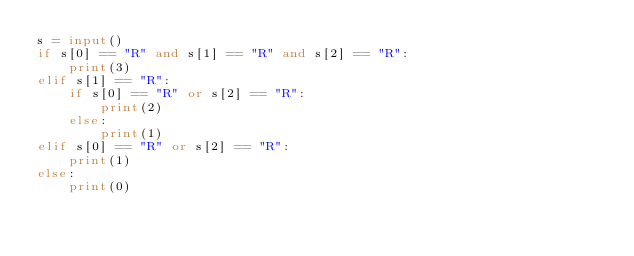<code> <loc_0><loc_0><loc_500><loc_500><_Python_>s = input()
if s[0] == "R" and s[1] == "R" and s[2] == "R":
    print(3)
elif s[1] == "R":
    if s[0] == "R" or s[2] == "R":
        print(2)
    else:
        print(1)
elif s[0] == "R" or s[2] == "R":
    print(1)
else:
    print(0)</code> 